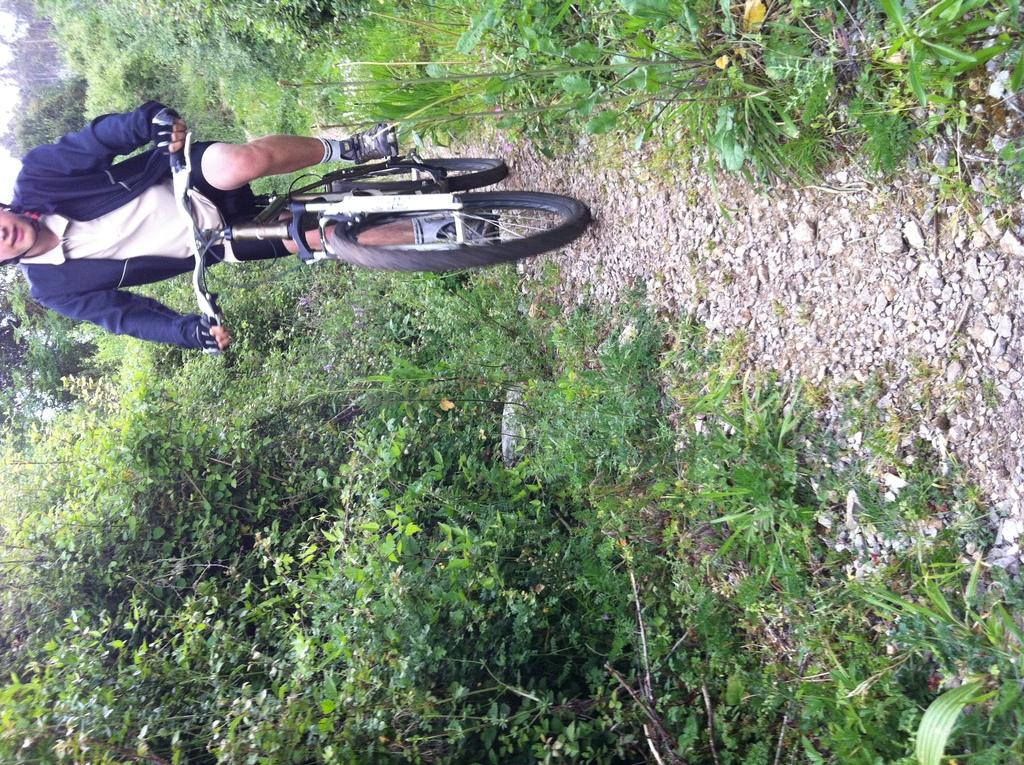What is the person in the image doing? The person is cycling in the image. What mode of transportation is the person using? The person is riding a cycle. What can be seen in the background of the image? There are trees visible in the image. What type of sweater is the person wearing while cycling in the image? There is no mention of a sweater in the image, so it cannot be determined what type the person might be wearing. 